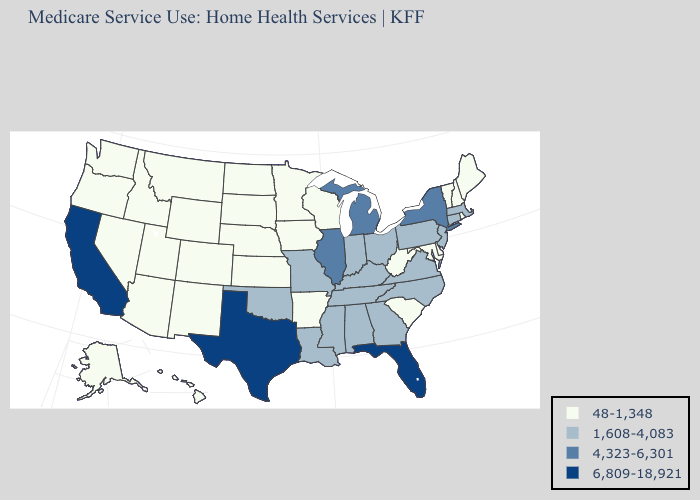Does Washington have the lowest value in the West?
Answer briefly. Yes. What is the value of Montana?
Write a very short answer. 48-1,348. Which states have the lowest value in the MidWest?
Concise answer only. Iowa, Kansas, Minnesota, Nebraska, North Dakota, South Dakota, Wisconsin. What is the highest value in the Northeast ?
Keep it brief. 4,323-6,301. How many symbols are there in the legend?
Give a very brief answer. 4. Does New Mexico have the same value as Kansas?
Be succinct. Yes. What is the value of Mississippi?
Keep it brief. 1,608-4,083. What is the value of Maryland?
Answer briefly. 48-1,348. Does New Hampshire have the highest value in the Northeast?
Give a very brief answer. No. Does Idaho have the lowest value in the USA?
Be succinct. Yes. Name the states that have a value in the range 6,809-18,921?
Write a very short answer. California, Florida, Texas. Does the first symbol in the legend represent the smallest category?
Concise answer only. Yes. Does the map have missing data?
Give a very brief answer. No. What is the lowest value in the USA?
Write a very short answer. 48-1,348. 